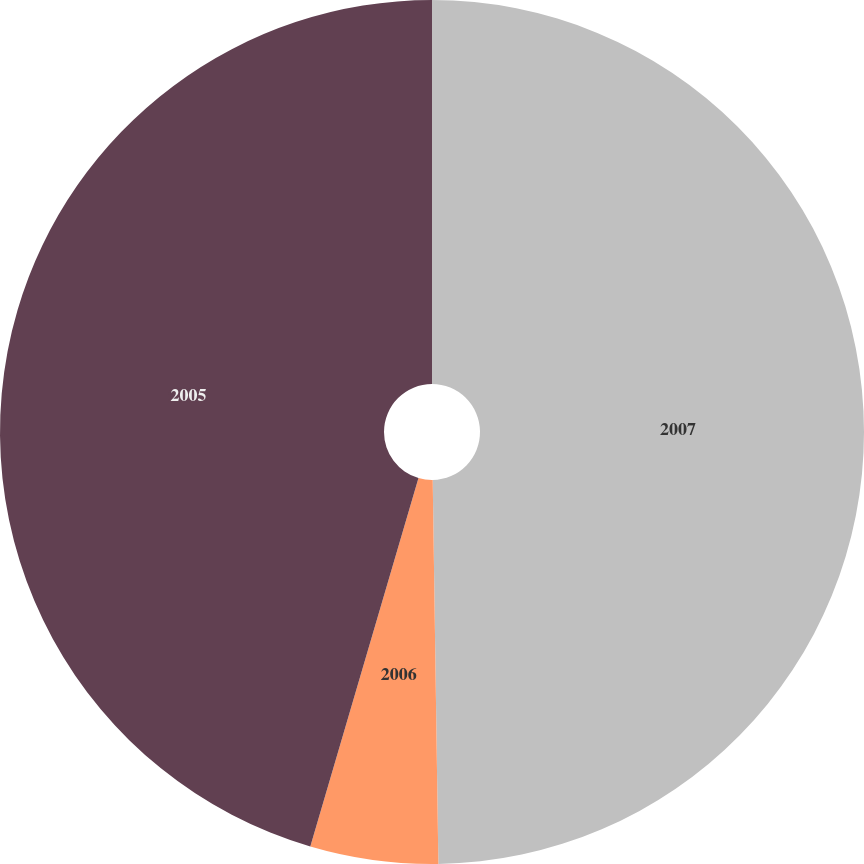<chart> <loc_0><loc_0><loc_500><loc_500><pie_chart><fcel>2007<fcel>2006<fcel>2005<nl><fcel>49.76%<fcel>4.78%<fcel>45.45%<nl></chart> 